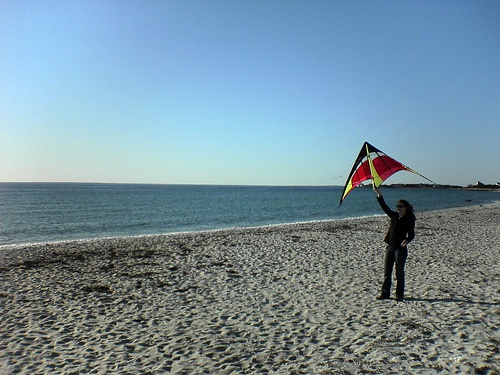Describe the objects in this image and their specific colors. I can see people in lightblue, black, gray, blue, and darkgray tones and kite in lightblue, maroon, black, brown, and darkgray tones in this image. 